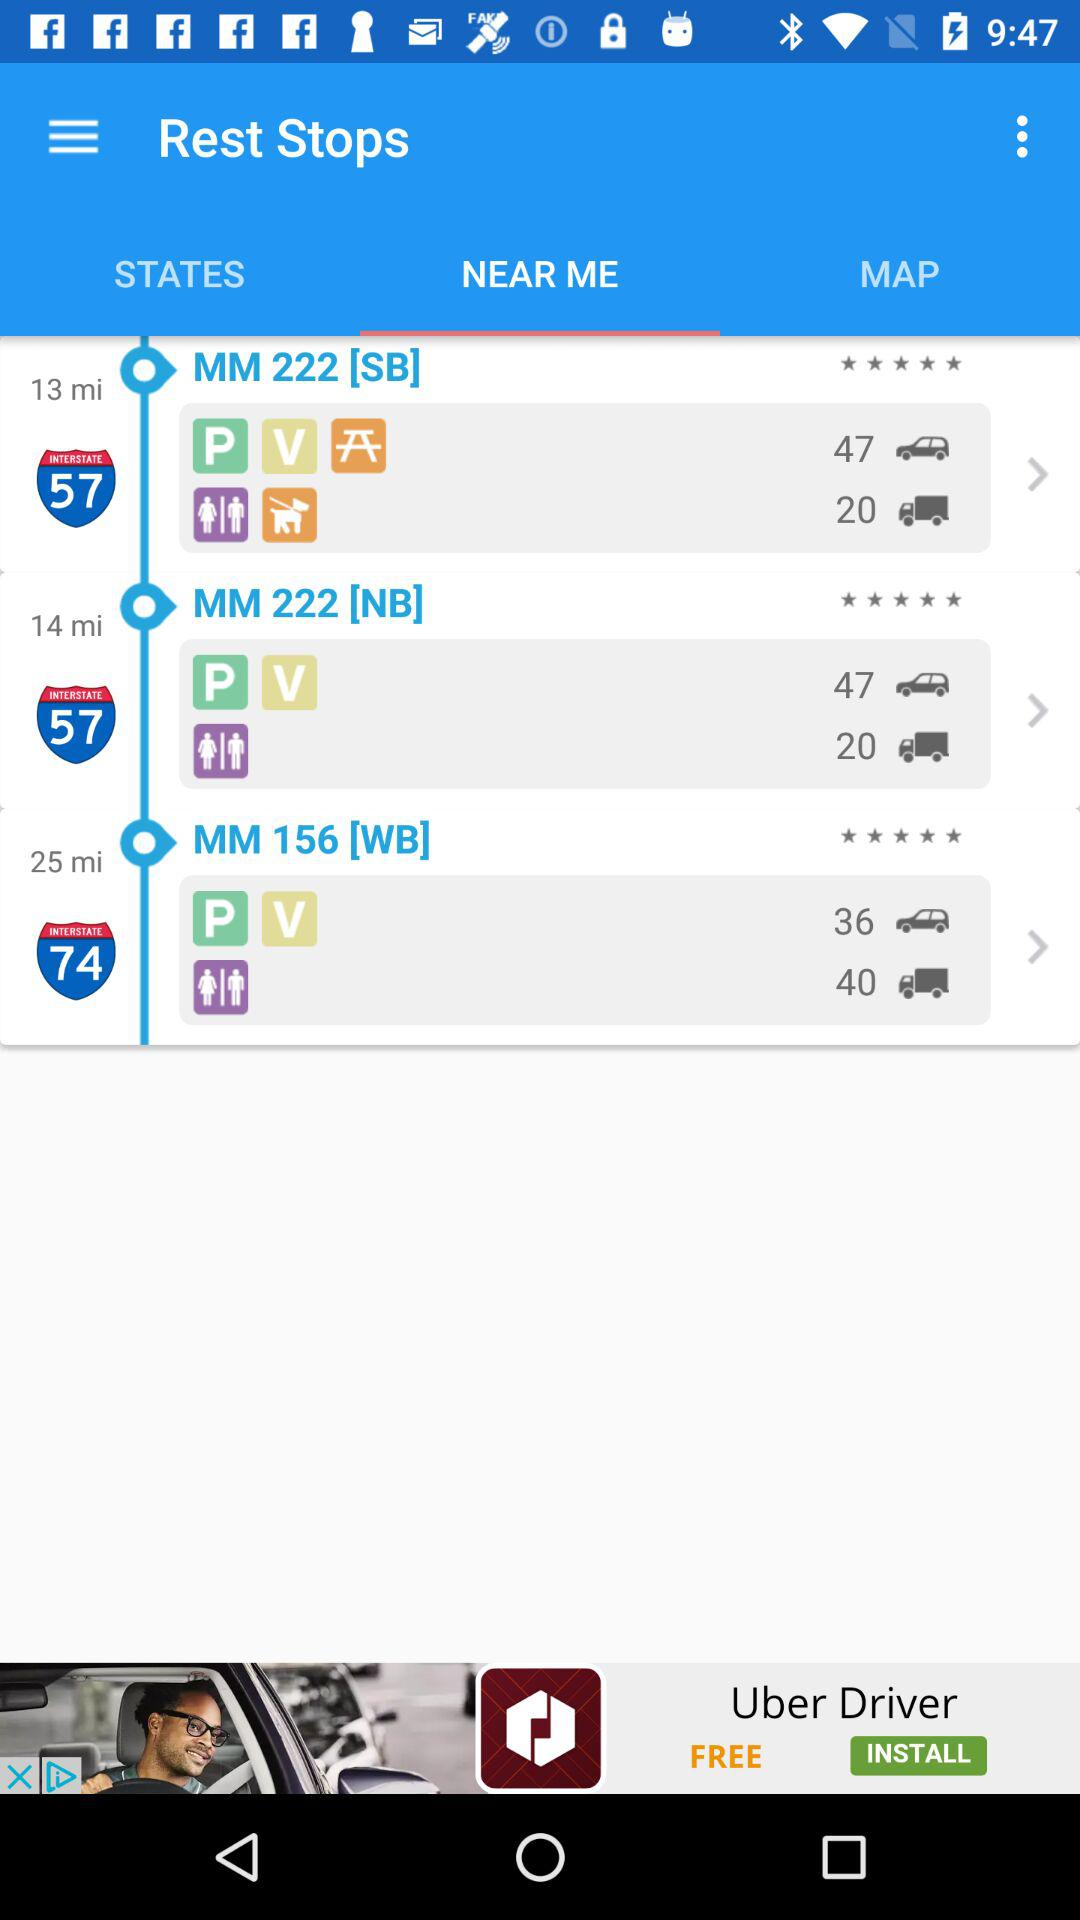How far away is MM 222 [SB] from my place? MM 222 [SB] is 13 miles away from your place. 